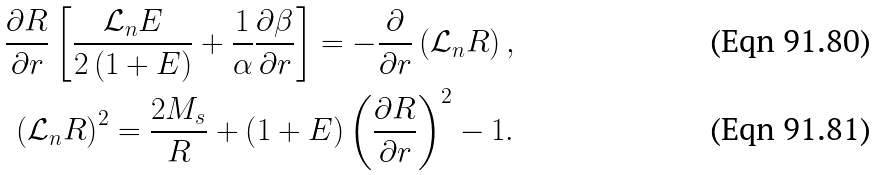<formula> <loc_0><loc_0><loc_500><loc_500>\frac { \partial R } { \partial r } \left [ \frac { \mathcal { L } _ { n } E } { 2 \left ( 1 + E \right ) } + \frac { 1 } { \alpha } \frac { \partial \beta } { \partial r } \right ] = - \frac { \partial } { \partial r } \left ( \mathcal { L } _ { n } R \right ) , \\ \left ( \mathcal { L } _ { n } R \right ) ^ { 2 } = \frac { 2 M _ { s } } { R } + \left ( 1 + E \right ) \left ( \frac { \partial R } { \partial r } \right ) ^ { 2 } - 1 .</formula> 